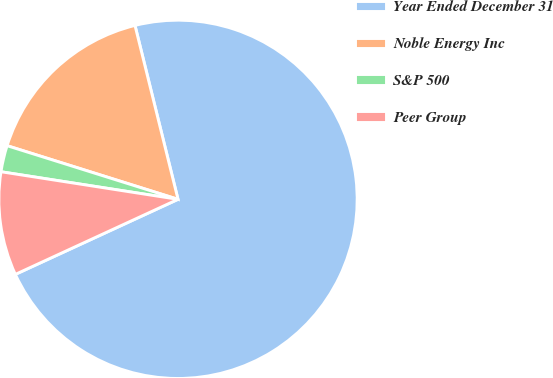Convert chart. <chart><loc_0><loc_0><loc_500><loc_500><pie_chart><fcel>Year Ended December 31<fcel>Noble Energy Inc<fcel>S&P 500<fcel>Peer Group<nl><fcel>71.98%<fcel>16.3%<fcel>2.38%<fcel>9.34%<nl></chart> 